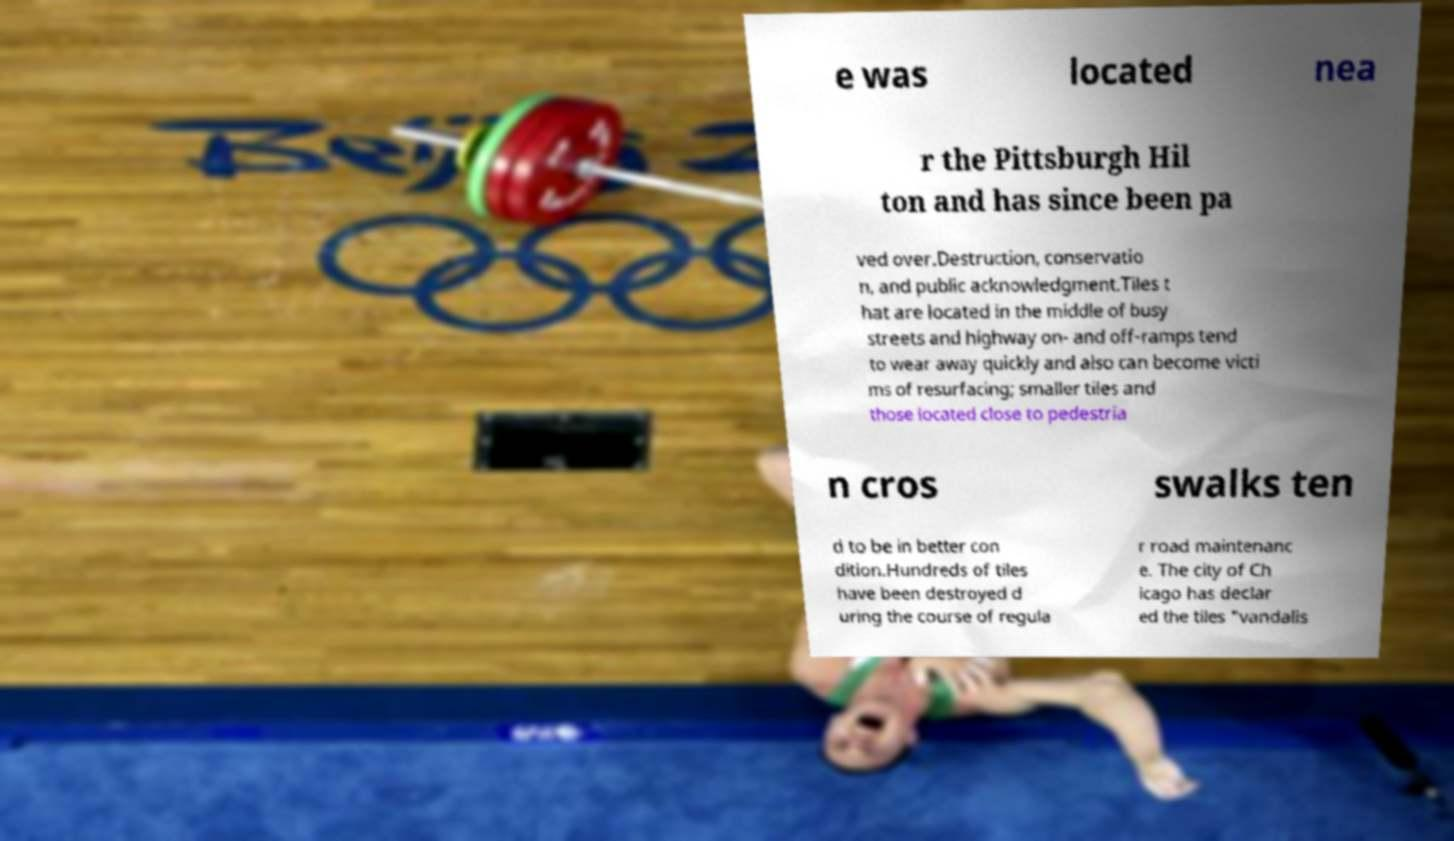There's text embedded in this image that I need extracted. Can you transcribe it verbatim? e was located nea r the Pittsburgh Hil ton and has since been pa ved over.Destruction, conservatio n, and public acknowledgment.Tiles t hat are located in the middle of busy streets and highway on- and off-ramps tend to wear away quickly and also can become victi ms of resurfacing; smaller tiles and those located close to pedestria n cros swalks ten d to be in better con dition.Hundreds of tiles have been destroyed d uring the course of regula r road maintenanc e. The city of Ch icago has declar ed the tiles "vandalis 